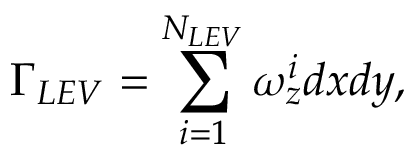<formula> <loc_0><loc_0><loc_500><loc_500>\Gamma _ { L E V } = \sum _ { i = 1 } ^ { N _ { L E V } } \omega _ { z } ^ { i } d x d y ,</formula> 